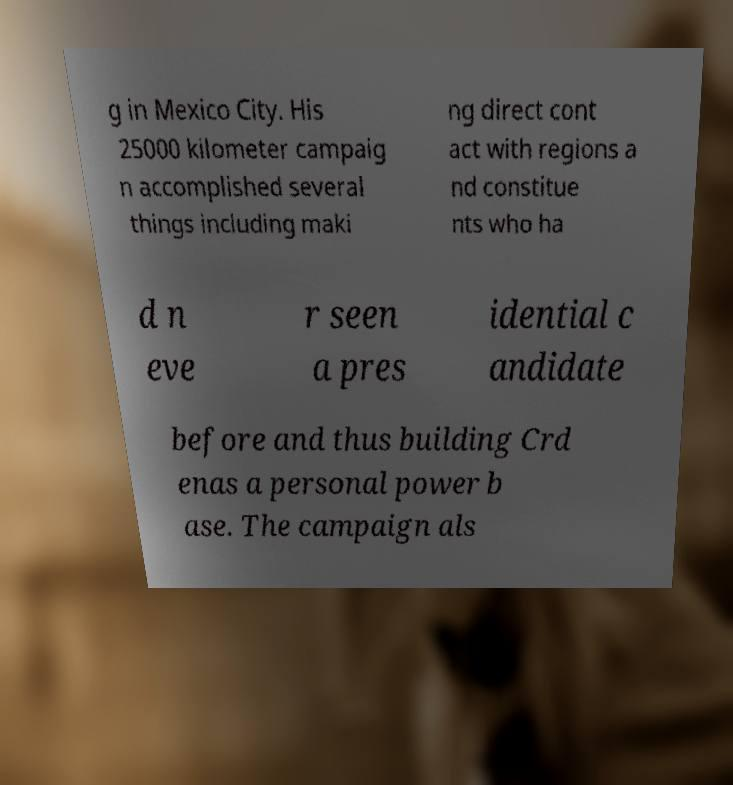Can you accurately transcribe the text from the provided image for me? g in Mexico City. His 25000 kilometer campaig n accomplished several things including maki ng direct cont act with regions a nd constitue nts who ha d n eve r seen a pres idential c andidate before and thus building Crd enas a personal power b ase. The campaign als 